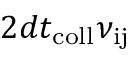<formula> <loc_0><loc_0><loc_500><loc_500>2 d t _ { c o l l } \nu _ { i j }</formula> 